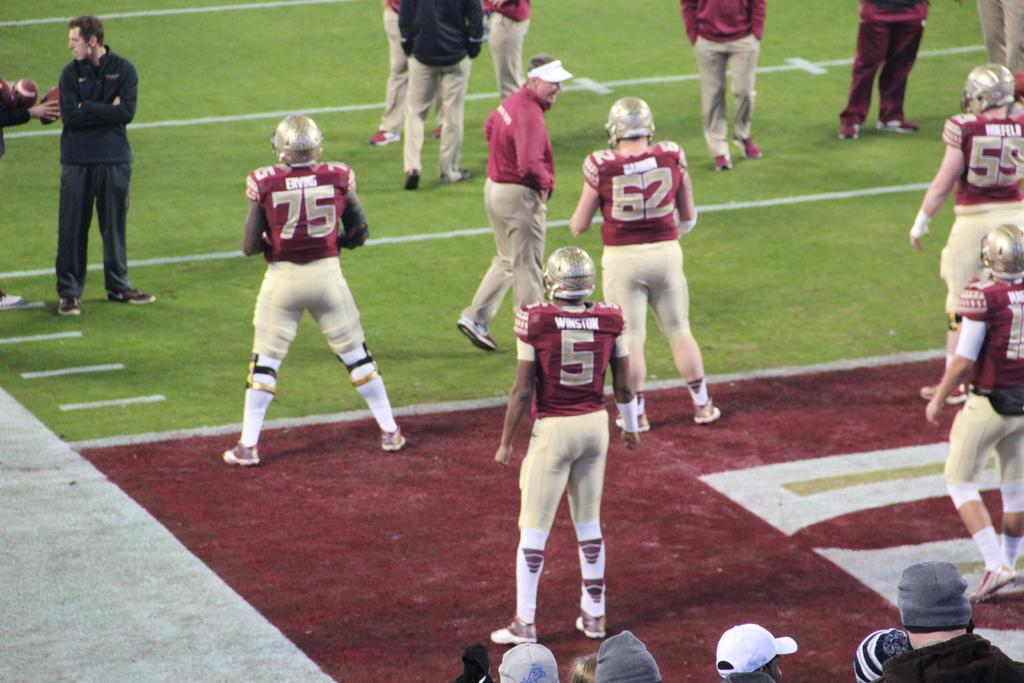What is the primary surface visible in the image? There is a ground in the image. What are the people doing on the ground? The people are standing on the ground. What type of trade is being conducted by the people in the image? There is no indication of any trade being conducted in the image; it simply shows people standing on the ground. 